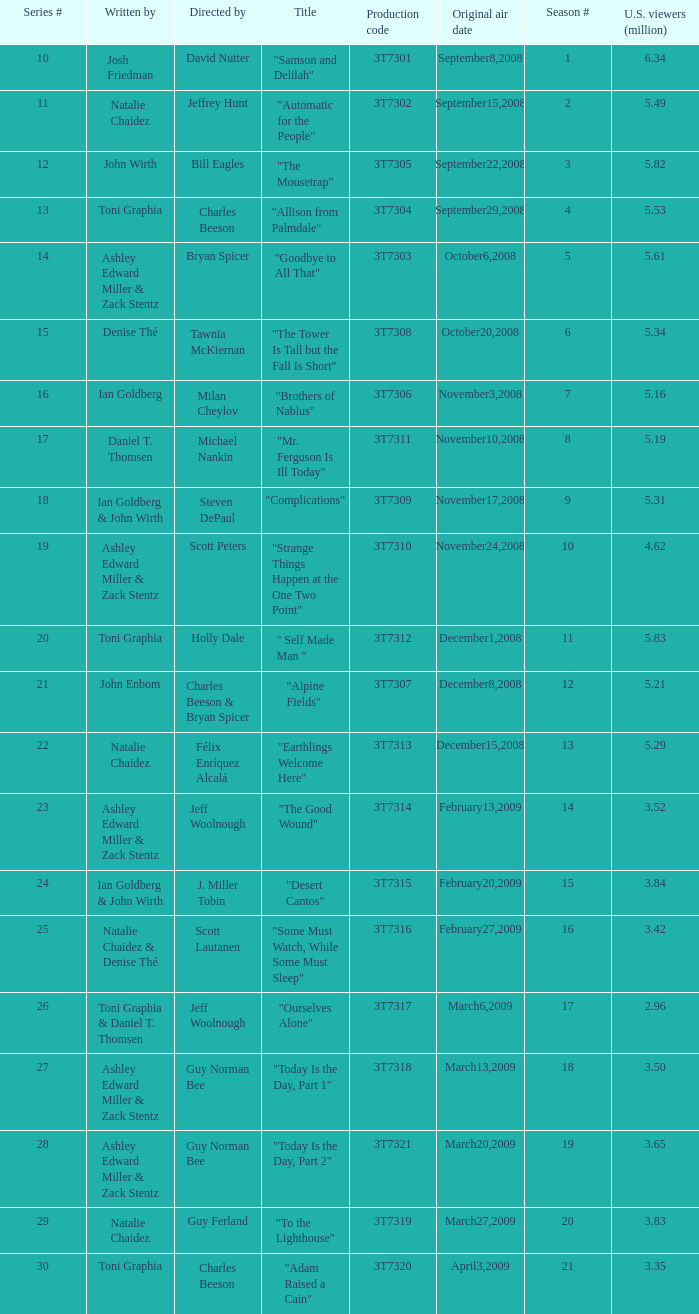How many viewers did the episode directed by David Nutter draw in? 6.34. Give me the full table as a dictionary. {'header': ['Series #', 'Written by', 'Directed by', 'Title', 'Production code', 'Original air date', 'Season #', 'U.S. viewers (million)'], 'rows': [['10', 'Josh Friedman', 'David Nutter', '"Samson and Delilah"', '3T7301', 'September8,2008', '1', '6.34'], ['11', 'Natalie Chaidez', 'Jeffrey Hunt', '"Automatic for the People"', '3T7302', 'September15,2008', '2', '5.49'], ['12', 'John Wirth', 'Bill Eagles', '"The Mousetrap"', '3T7305', 'September22,2008', '3', '5.82'], ['13', 'Toni Graphia', 'Charles Beeson', '"Allison from Palmdale"', '3T7304', 'September29,2008', '4', '5.53'], ['14', 'Ashley Edward Miller & Zack Stentz', 'Bryan Spicer', '"Goodbye to All That"', '3T7303', 'October6,2008', '5', '5.61'], ['15', 'Denise Thé', 'Tawnia McKiernan', '"The Tower Is Tall but the Fall Is Short"', '3T7308', 'October20,2008', '6', '5.34'], ['16', 'Ian Goldberg', 'Milan Cheylov', '"Brothers of Nablus"', '3T7306', 'November3,2008', '7', '5.16'], ['17', 'Daniel T. Thomsen', 'Michael Nankin', '"Mr. Ferguson Is Ill Today"', '3T7311', 'November10,2008', '8', '5.19'], ['18', 'Ian Goldberg & John Wirth', 'Steven DePaul', '"Complications"', '3T7309', 'November17,2008', '9', '5.31'], ['19', 'Ashley Edward Miller & Zack Stentz', 'Scott Peters', '"Strange Things Happen at the One Two Point"', '3T7310', 'November24,2008', '10', '4.62'], ['20', 'Toni Graphia', 'Holly Dale', '" Self Made Man "', '3T7312', 'December1,2008', '11', '5.83'], ['21', 'John Enbom', 'Charles Beeson & Bryan Spicer', '"Alpine Fields"', '3T7307', 'December8,2008', '12', '5.21'], ['22', 'Natalie Chaidez', 'Félix Enríquez Alcalá', '"Earthlings Welcome Here"', '3T7313', 'December15,2008', '13', '5.29'], ['23', 'Ashley Edward Miller & Zack Stentz', 'Jeff Woolnough', '"The Good Wound"', '3T7314', 'February13,2009', '14', '3.52'], ['24', 'Ian Goldberg & John Wirth', 'J. Miller Tobin', '"Desert Cantos"', '3T7315', 'February20,2009', '15', '3.84'], ['25', 'Natalie Chaidez & Denise Thé', 'Scott Lautanen', '"Some Must Watch, While Some Must Sleep"', '3T7316', 'February27,2009', '16', '3.42'], ['26', 'Toni Graphia & Daniel T. Thomsen', 'Jeff Woolnough', '"Ourselves Alone"', '3T7317', 'March6,2009', '17', '2.96'], ['27', 'Ashley Edward Miller & Zack Stentz', 'Guy Norman Bee', '"Today Is the Day, Part 1"', '3T7318', 'March13,2009', '18', '3.50'], ['28', 'Ashley Edward Miller & Zack Stentz', 'Guy Norman Bee', '"Today Is the Day, Part 2"', '3T7321', 'March20,2009', '19', '3.65'], ['29', 'Natalie Chaidez', 'Guy Ferland', '"To the Lighthouse"', '3T7319', 'March27,2009', '20', '3.83'], ['30', 'Toni Graphia', 'Charles Beeson', '"Adam Raised a Cain"', '3T7320', 'April3,2009', '21', '3.35']]} 